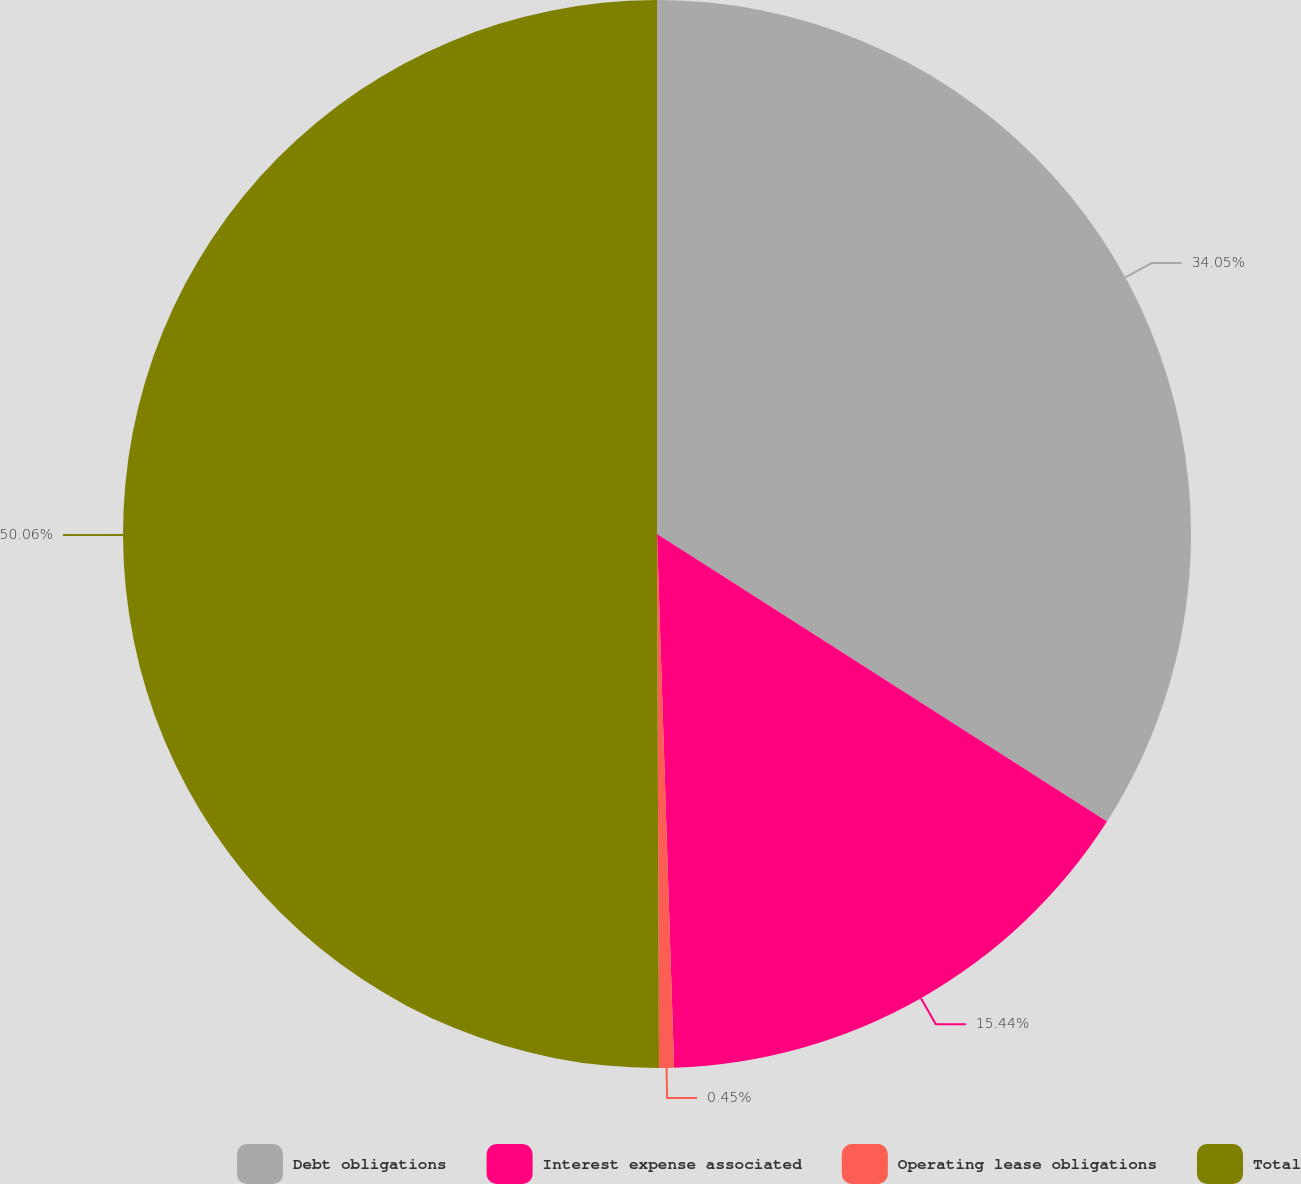Convert chart. <chart><loc_0><loc_0><loc_500><loc_500><pie_chart><fcel>Debt obligations<fcel>Interest expense associated<fcel>Operating lease obligations<fcel>Total<nl><fcel>34.05%<fcel>15.44%<fcel>0.45%<fcel>50.06%<nl></chart> 